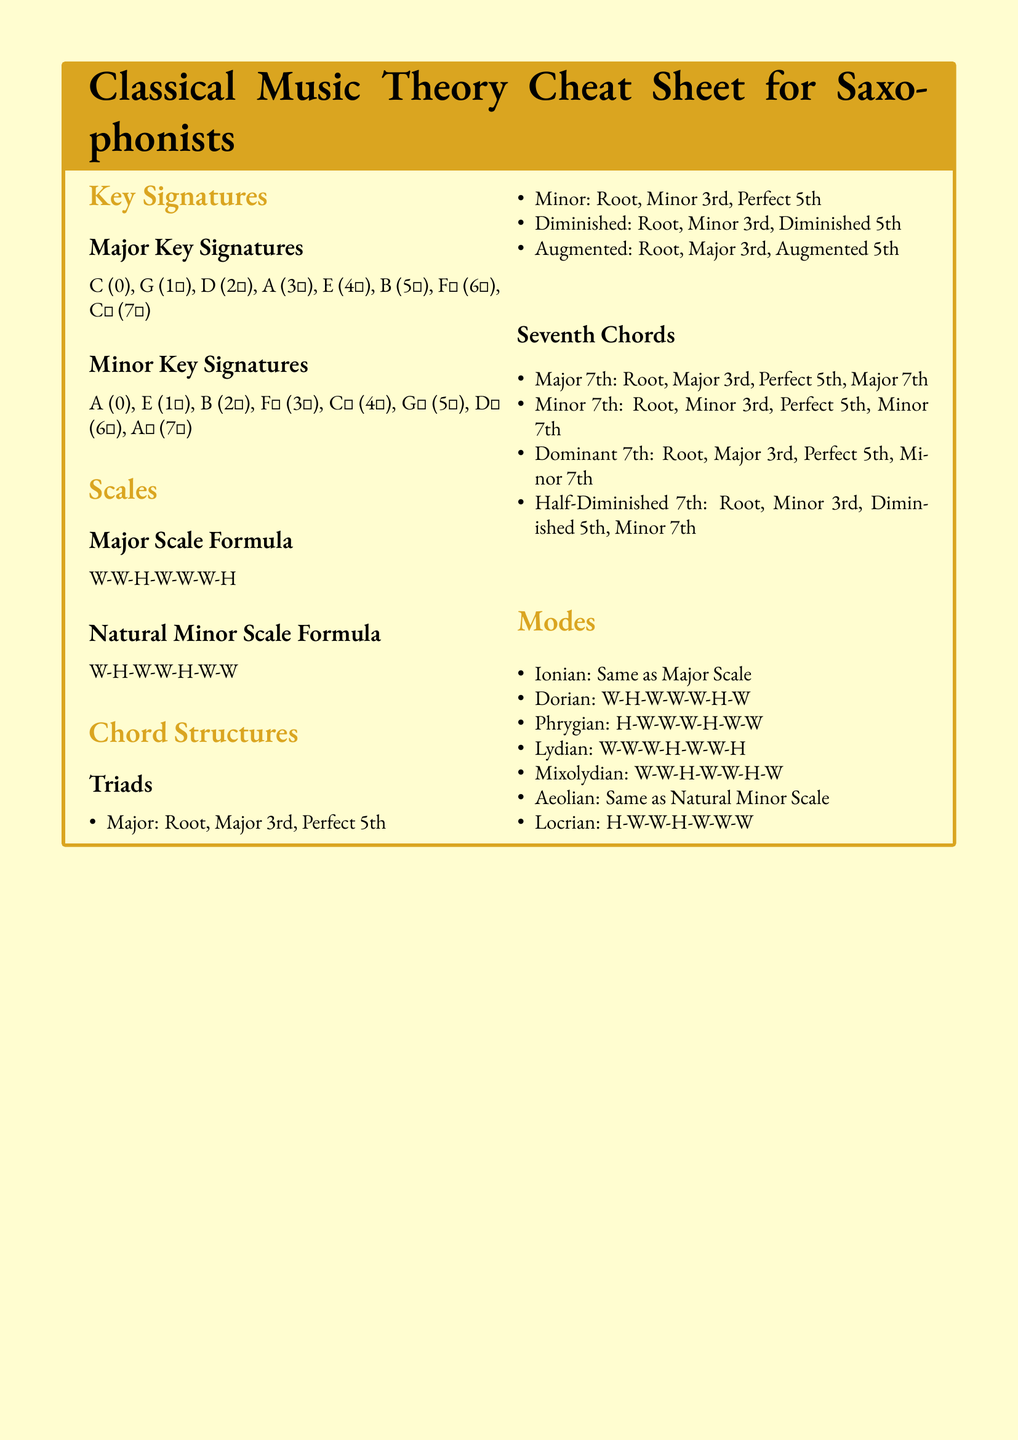What is the formula for the Major Scale? The Major Scale Formula is a specific sequence of whole and half steps, which is listed in the document.
Answer: W-W-H-W-W-W-H How many sharps are in the key of E Major? The key signature section provides the number of sharps in various major keys, including E Major.
Answer: 4♯ What is the structure of a Minor triad? The chord structures section outlines the components of different triads, including Minor triads.
Answer: Root, Minor 3rd, Perfect 5th What mode is the same as the Major scale? The modes section presents various modes and specifies which ones are equivalent to other scales, such as the Major scale.
Answer: Ionian How many notes are in a Major 7th chord? Based on the chord structures section, the Major 7th chord has four specific notes.
Answer: 4 What does the Locrian mode start with? The modes section lists the formula for the Locrian mode, indicating the initial interval.
Answer: H Which key signature has no sharps or flats? The key signatures section indicates which major and minor keys have no sharps or flats.
Answer: C What is the structure of a Half-Diminished 7th chord? The seventh chords section describes the notes that make up specific chords, including Half-Diminished 7th chords.
Answer: Root, Minor 3rd, Diminished 5th, Minor 7th What is the difference between a Major and Minor triad? The chord structures section differentiates the components of Major and Minor triads.
Answer: Thirds 